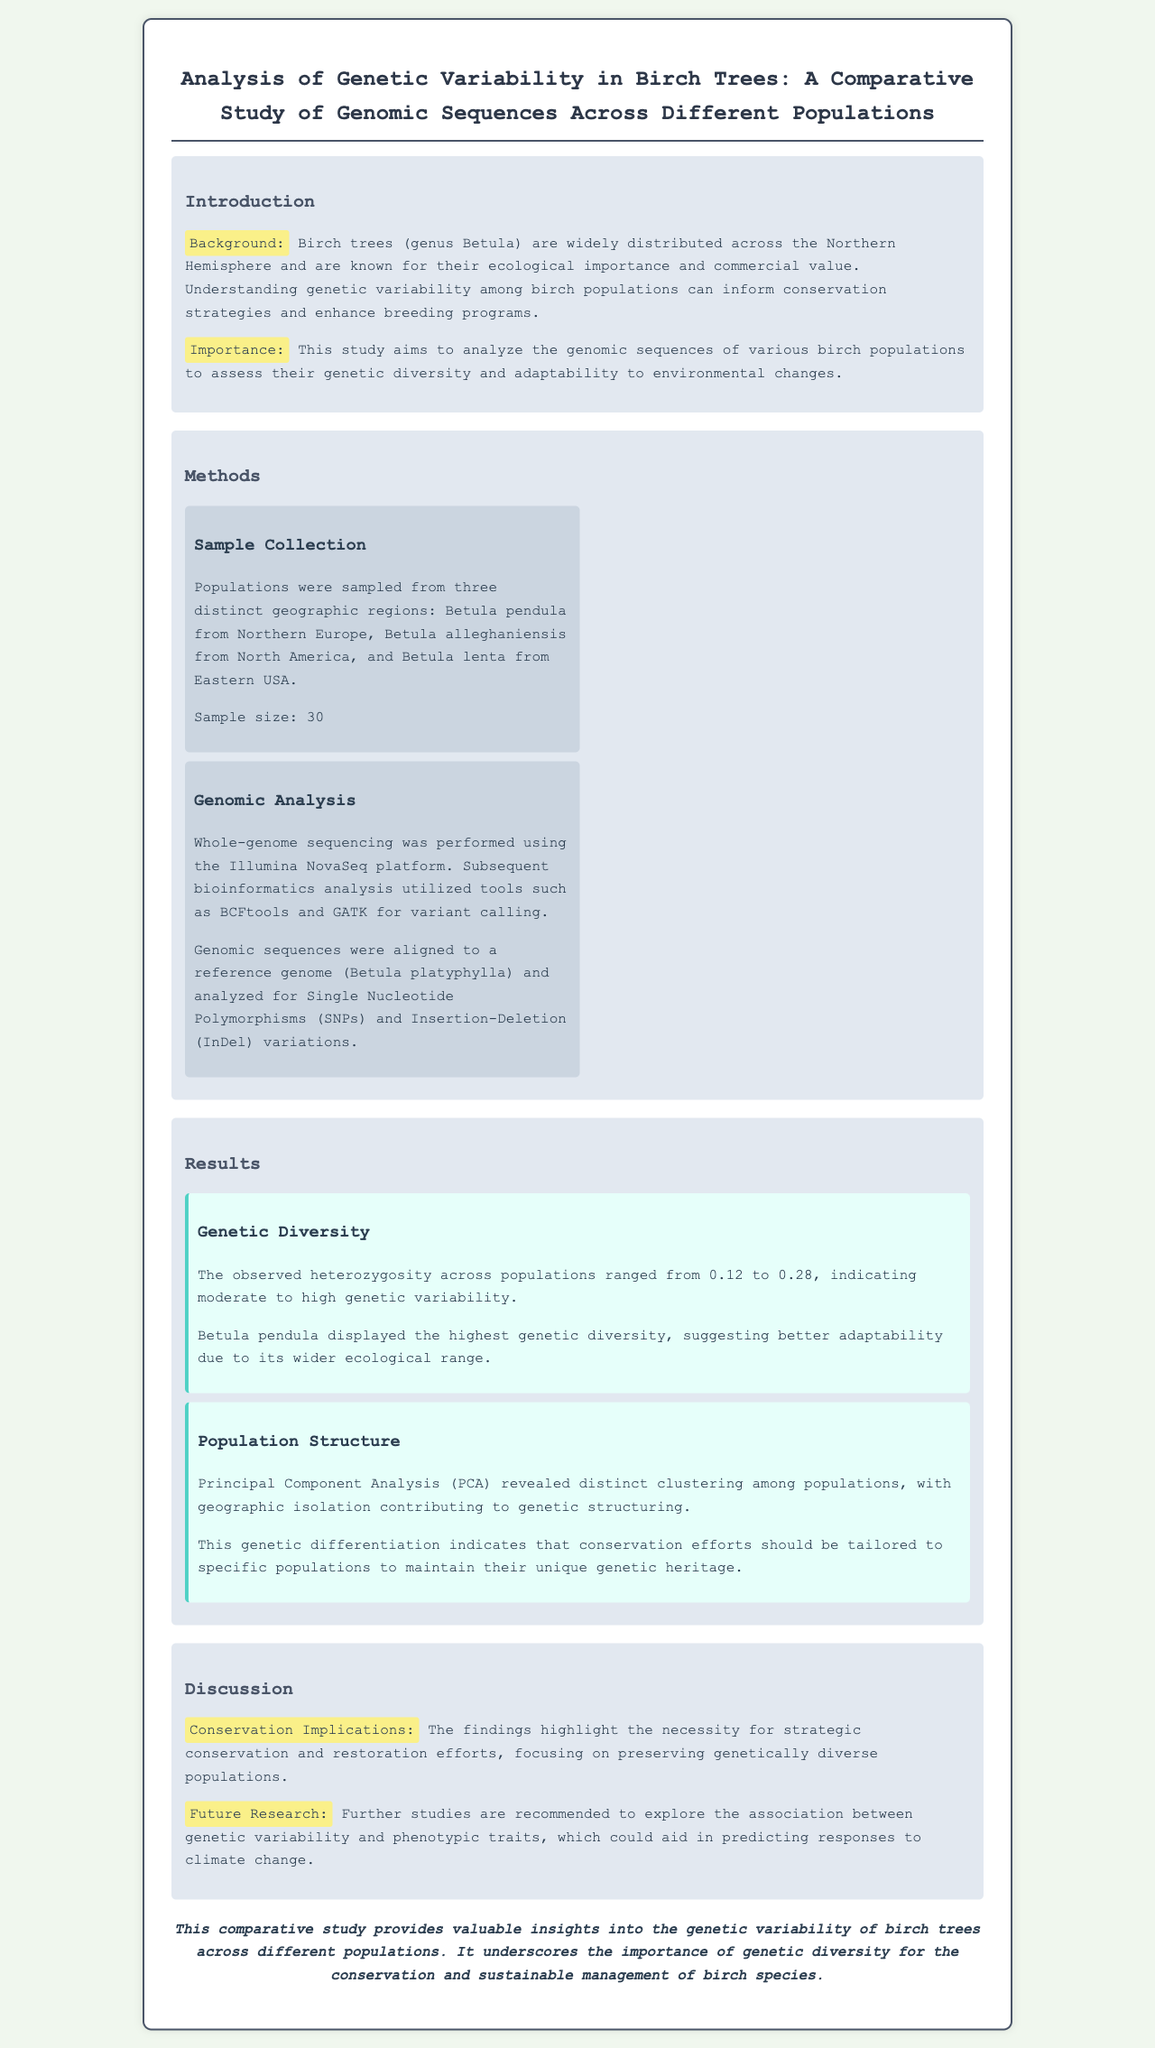What is the focus of the study? The study focuses on analyzing genetic variability among birch populations to assess their diversity and adaptability.
Answer: genetic variability What platforms were used for whole-genome sequencing? The document states that Illumina NovaSeq was used for whole-genome sequencing.
Answer: Illumina NovaSeq How many populations were sampled in the study? The sample size indicated in the document is 30.
Answer: 30 Which birch species displayed the highest genetic diversity? The document specifies that Betula pendula displayed the highest genetic diversity.
Answer: Betula pendula What does PCA reveal about the birch populations? PCA revealed distinct clustering among populations, indicating genetic structuring due to geographic isolation.
Answer: distinct clustering What is the observed heterozygosity range across populations? The observed heterozygosity ranged from 0.12 to 0.28 across populations.
Answer: 0.12 to 0.28 What are the conservation implications of the study? The study indicates the necessity for strategic conservation efforts to preserve genetically diverse populations.
Answer: strategic conservation What further studies are recommended? The document recommends further studies to explore the association between genetic variability and phenotypic traits.
Answer: association between genetic variability and phenotypic traits 